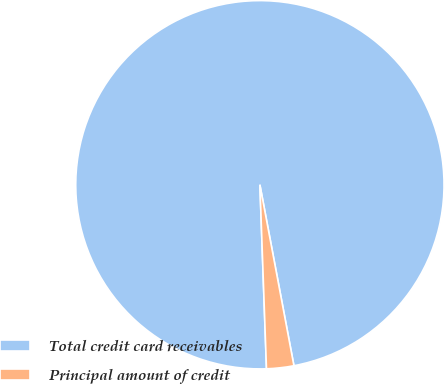Convert chart. <chart><loc_0><loc_0><loc_500><loc_500><pie_chart><fcel>Total credit card receivables<fcel>Principal amount of credit<nl><fcel>97.61%<fcel>2.39%<nl></chart> 